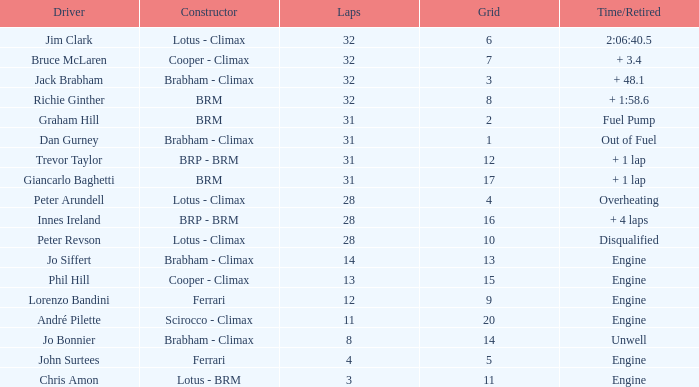What is the average grid for jack brabham going over 32 laps? None. 